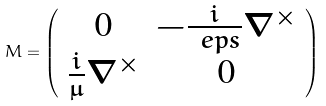<formula> <loc_0><loc_0><loc_500><loc_500>M = \left ( \begin{array} { c c } 0 & - \frac { i } { \ e p s } \nabla ^ { \times } \\ \frac { i } { \mu } \nabla ^ { \times } & 0 \\ \end{array} \right )</formula> 